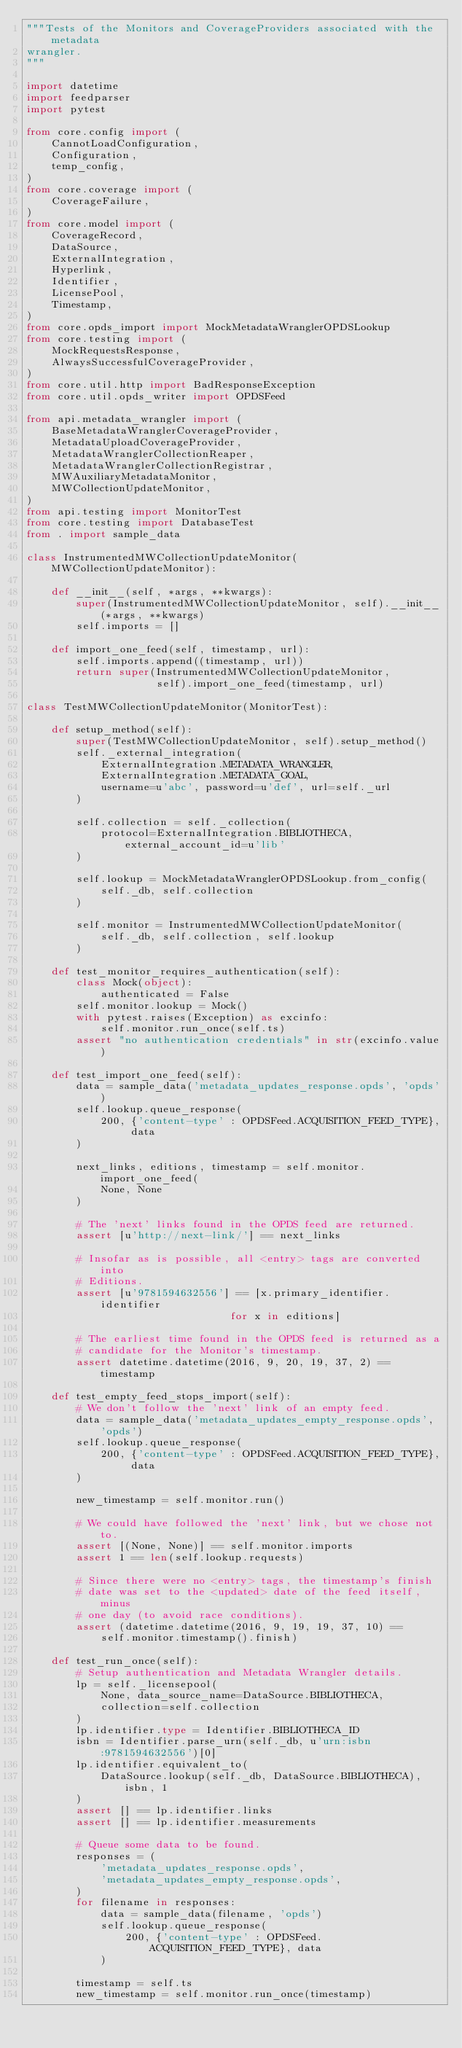Convert code to text. <code><loc_0><loc_0><loc_500><loc_500><_Python_>"""Tests of the Monitors and CoverageProviders associated with the metadata
wrangler.
"""

import datetime
import feedparser
import pytest

from core.config import (
    CannotLoadConfiguration,
    Configuration,
    temp_config,
)
from core.coverage import (
    CoverageFailure,
)
from core.model import (
    CoverageRecord,
    DataSource,
    ExternalIntegration,
    Hyperlink,
    Identifier,
    LicensePool,
    Timestamp,
)
from core.opds_import import MockMetadataWranglerOPDSLookup
from core.testing import (
    MockRequestsResponse,
    AlwaysSuccessfulCoverageProvider,
)
from core.util.http import BadResponseException
from core.util.opds_writer import OPDSFeed

from api.metadata_wrangler import (
    BaseMetadataWranglerCoverageProvider,
    MetadataUploadCoverageProvider,
    MetadataWranglerCollectionReaper,
    MetadataWranglerCollectionRegistrar,
    MWAuxiliaryMetadataMonitor,
    MWCollectionUpdateMonitor,
)
from api.testing import MonitorTest
from core.testing import DatabaseTest
from . import sample_data

class InstrumentedMWCollectionUpdateMonitor(MWCollectionUpdateMonitor):

    def __init__(self, *args, **kwargs):
        super(InstrumentedMWCollectionUpdateMonitor, self).__init__(*args, **kwargs)
        self.imports = []

    def import_one_feed(self, timestamp, url):
        self.imports.append((timestamp, url))
        return super(InstrumentedMWCollectionUpdateMonitor,
                     self).import_one_feed(timestamp, url)

class TestMWCollectionUpdateMonitor(MonitorTest):

    def setup_method(self):
        super(TestMWCollectionUpdateMonitor, self).setup_method()
        self._external_integration(
            ExternalIntegration.METADATA_WRANGLER,
            ExternalIntegration.METADATA_GOAL,
            username=u'abc', password=u'def', url=self._url
        )

        self.collection = self._collection(
            protocol=ExternalIntegration.BIBLIOTHECA, external_account_id=u'lib'
        )

        self.lookup = MockMetadataWranglerOPDSLookup.from_config(
            self._db, self.collection
        )

        self.monitor = InstrumentedMWCollectionUpdateMonitor(
            self._db, self.collection, self.lookup
        )

    def test_monitor_requires_authentication(self):
        class Mock(object):
            authenticated = False
        self.monitor.lookup = Mock()
        with pytest.raises(Exception) as excinfo:
            self.monitor.run_once(self.ts)
        assert "no authentication credentials" in str(excinfo.value)

    def test_import_one_feed(self):
        data = sample_data('metadata_updates_response.opds', 'opds')
        self.lookup.queue_response(
            200, {'content-type' : OPDSFeed.ACQUISITION_FEED_TYPE}, data
        )

        next_links, editions, timestamp = self.monitor.import_one_feed(
            None, None
        )

        # The 'next' links found in the OPDS feed are returned.
        assert [u'http://next-link/'] == next_links

        # Insofar as is possible, all <entry> tags are converted into
        # Editions.
        assert [u'9781594632556'] == [x.primary_identifier.identifier
                                 for x in editions]

        # The earliest time found in the OPDS feed is returned as a
        # candidate for the Monitor's timestamp.
        assert datetime.datetime(2016, 9, 20, 19, 37, 2) == timestamp

    def test_empty_feed_stops_import(self):
        # We don't follow the 'next' link of an empty feed.
        data = sample_data('metadata_updates_empty_response.opds', 'opds')
        self.lookup.queue_response(
            200, {'content-type' : OPDSFeed.ACQUISITION_FEED_TYPE}, data
        )

        new_timestamp = self.monitor.run()

        # We could have followed the 'next' link, but we chose not to.
        assert [(None, None)] == self.monitor.imports
        assert 1 == len(self.lookup.requests)

        # Since there were no <entry> tags, the timestamp's finish
        # date was set to the <updated> date of the feed itself, minus
        # one day (to avoid race conditions).
        assert (datetime.datetime(2016, 9, 19, 19, 37, 10) ==
            self.monitor.timestamp().finish)

    def test_run_once(self):
        # Setup authentication and Metadata Wrangler details.
        lp = self._licensepool(
            None, data_source_name=DataSource.BIBLIOTHECA,
            collection=self.collection
        )
        lp.identifier.type = Identifier.BIBLIOTHECA_ID
        isbn = Identifier.parse_urn(self._db, u'urn:isbn:9781594632556')[0]
        lp.identifier.equivalent_to(
            DataSource.lookup(self._db, DataSource.BIBLIOTHECA), isbn, 1
        )
        assert [] == lp.identifier.links
        assert [] == lp.identifier.measurements

        # Queue some data to be found.
        responses = (
            'metadata_updates_response.opds',
            'metadata_updates_empty_response.opds',
        )
        for filename in responses:
            data = sample_data(filename, 'opds')
            self.lookup.queue_response(
                200, {'content-type' : OPDSFeed.ACQUISITION_FEED_TYPE}, data
            )

        timestamp = self.ts
        new_timestamp = self.monitor.run_once(timestamp)
</code> 